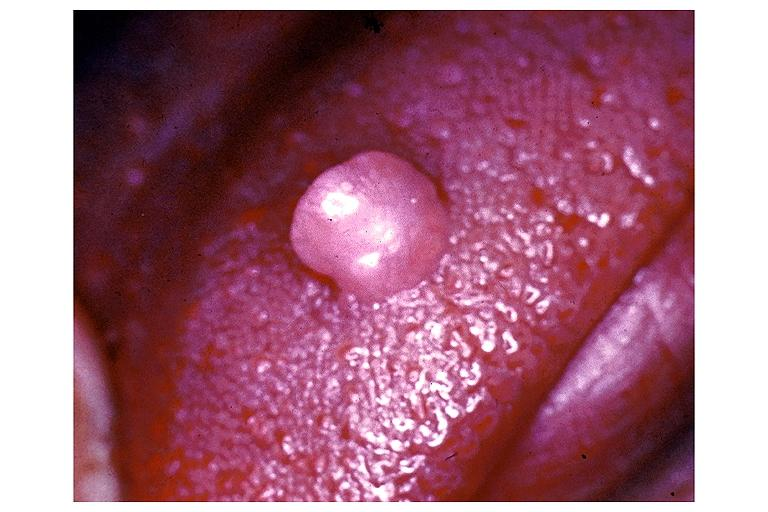does this image show irritation fibroma?
Answer the question using a single word or phrase. Yes 